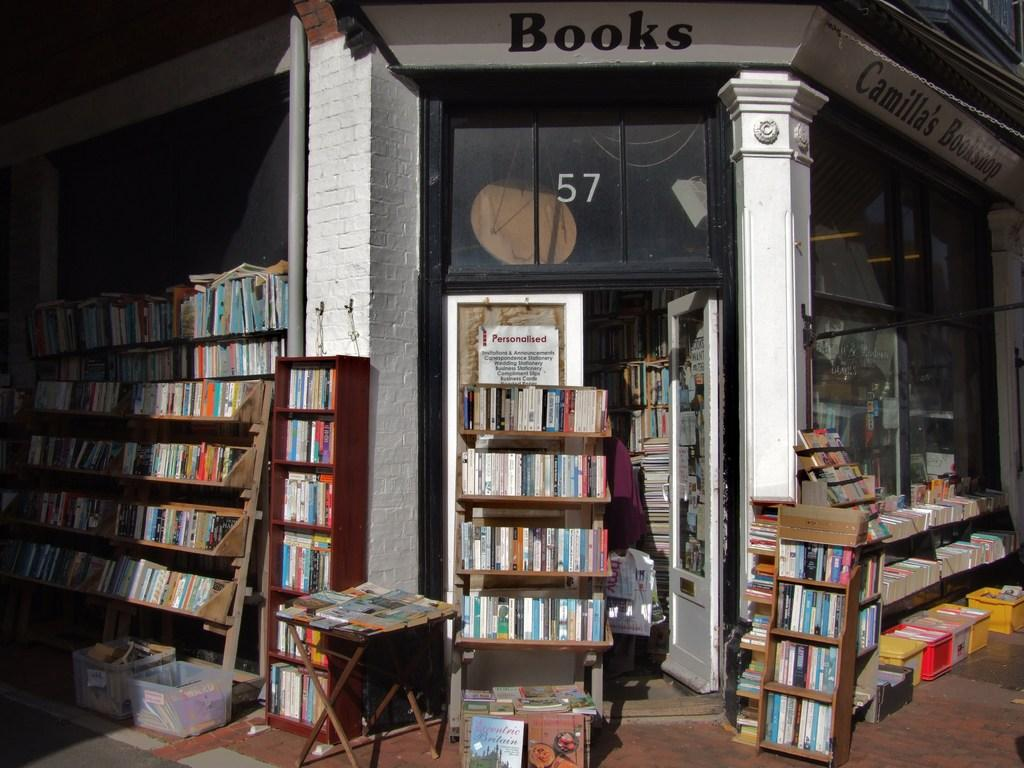Provide a one-sentence caption for the provided image. a building with the number 57 on it. 